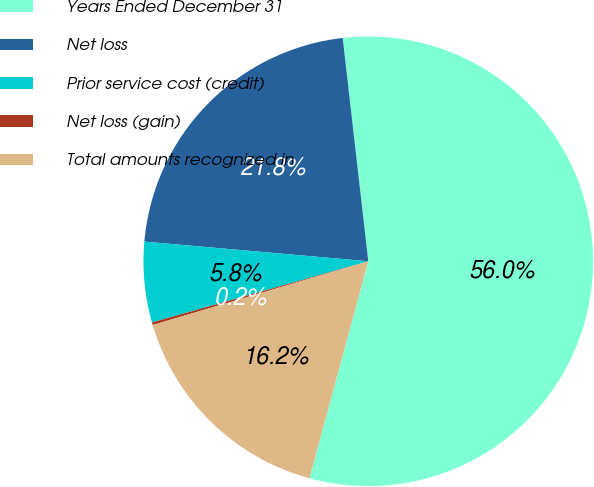Convert chart. <chart><loc_0><loc_0><loc_500><loc_500><pie_chart><fcel>Years Ended December 31<fcel>Net loss<fcel>Prior service cost (credit)<fcel>Net loss (gain)<fcel>Total amounts recognized in<nl><fcel>56.03%<fcel>21.79%<fcel>5.78%<fcel>0.19%<fcel>16.21%<nl></chart> 